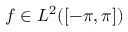Convert formula to latex. <formula><loc_0><loc_0><loc_500><loc_500>f \in L ^ { 2 } ( [ - \pi , \pi ] )</formula> 